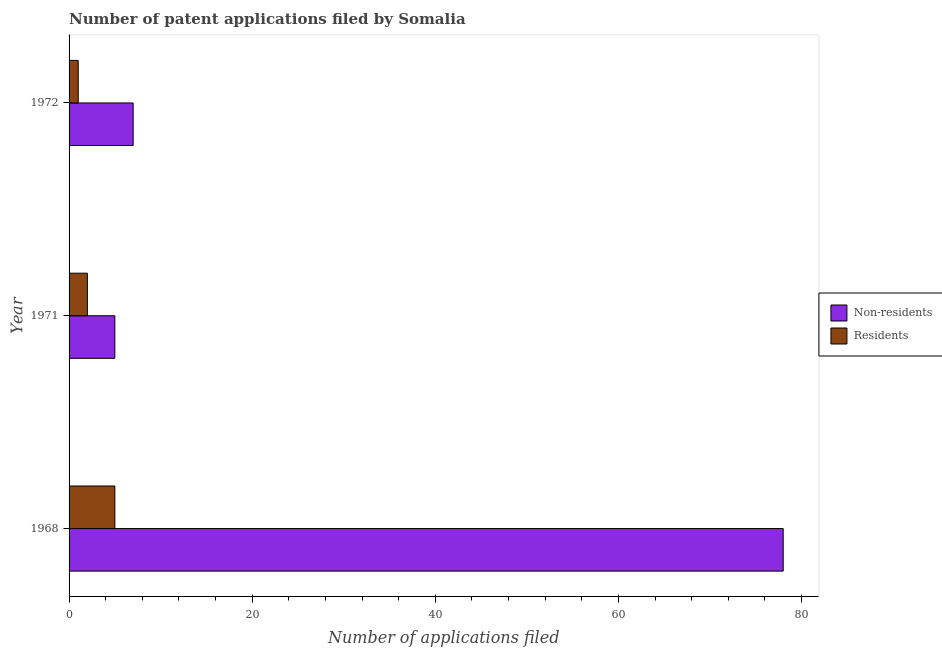How many different coloured bars are there?
Offer a very short reply. 2. Are the number of bars per tick equal to the number of legend labels?
Offer a very short reply. Yes. Are the number of bars on each tick of the Y-axis equal?
Your answer should be very brief. Yes. How many bars are there on the 3rd tick from the top?
Your answer should be very brief. 2. How many bars are there on the 3rd tick from the bottom?
Your answer should be very brief. 2. What is the label of the 1st group of bars from the top?
Provide a short and direct response. 1972. What is the number of patent applications by residents in 1968?
Keep it short and to the point. 5. Across all years, what is the maximum number of patent applications by residents?
Your response must be concise. 5. Across all years, what is the minimum number of patent applications by residents?
Give a very brief answer. 1. In which year was the number of patent applications by non residents maximum?
Your answer should be compact. 1968. In which year was the number of patent applications by residents minimum?
Offer a terse response. 1972. What is the total number of patent applications by residents in the graph?
Your answer should be compact. 8. What is the difference between the number of patent applications by residents in 1971 and that in 1972?
Your response must be concise. 1. What is the difference between the number of patent applications by residents in 1971 and the number of patent applications by non residents in 1972?
Offer a very short reply. -5. In the year 1971, what is the difference between the number of patent applications by non residents and number of patent applications by residents?
Keep it short and to the point. 3. Is the number of patent applications by residents in 1968 less than that in 1972?
Offer a very short reply. No. What is the difference between the highest and the second highest number of patent applications by non residents?
Make the answer very short. 71. What is the difference between the highest and the lowest number of patent applications by non residents?
Make the answer very short. 73. Is the sum of the number of patent applications by residents in 1968 and 1972 greater than the maximum number of patent applications by non residents across all years?
Offer a very short reply. No. What does the 1st bar from the top in 1972 represents?
Your answer should be compact. Residents. What does the 2nd bar from the bottom in 1972 represents?
Give a very brief answer. Residents. How many bars are there?
Offer a very short reply. 6. What is the difference between two consecutive major ticks on the X-axis?
Make the answer very short. 20. Are the values on the major ticks of X-axis written in scientific E-notation?
Offer a very short reply. No. Does the graph contain any zero values?
Provide a succinct answer. No. How many legend labels are there?
Keep it short and to the point. 2. How are the legend labels stacked?
Make the answer very short. Vertical. What is the title of the graph?
Your answer should be very brief. Number of patent applications filed by Somalia. What is the label or title of the X-axis?
Your response must be concise. Number of applications filed. What is the label or title of the Y-axis?
Ensure brevity in your answer.  Year. What is the Number of applications filed in Non-residents in 1971?
Keep it short and to the point. 5. What is the Number of applications filed in Residents in 1971?
Your response must be concise. 2. What is the Number of applications filed in Non-residents in 1972?
Offer a very short reply. 7. What is the total Number of applications filed of Non-residents in the graph?
Make the answer very short. 90. What is the difference between the Number of applications filed of Residents in 1968 and that in 1971?
Offer a terse response. 3. What is the difference between the Number of applications filed of Non-residents in 1968 and the Number of applications filed of Residents in 1971?
Your answer should be compact. 76. What is the average Number of applications filed of Non-residents per year?
Ensure brevity in your answer.  30. What is the average Number of applications filed in Residents per year?
Ensure brevity in your answer.  2.67. What is the ratio of the Number of applications filed in Non-residents in 1968 to that in 1972?
Provide a short and direct response. 11.14. What is the ratio of the Number of applications filed in Non-residents in 1971 to that in 1972?
Your response must be concise. 0.71. What is the ratio of the Number of applications filed of Residents in 1971 to that in 1972?
Keep it short and to the point. 2. What is the difference between the highest and the second highest Number of applications filed of Non-residents?
Ensure brevity in your answer.  71. What is the difference between the highest and the second highest Number of applications filed in Residents?
Your answer should be compact. 3. What is the difference between the highest and the lowest Number of applications filed of Residents?
Your answer should be compact. 4. 